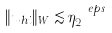<formula> <loc_0><loc_0><loc_500><loc_500>\| u _ { h i } \| _ { W } \lesssim \eta _ { 2 } ^ { \ e p s }</formula> 